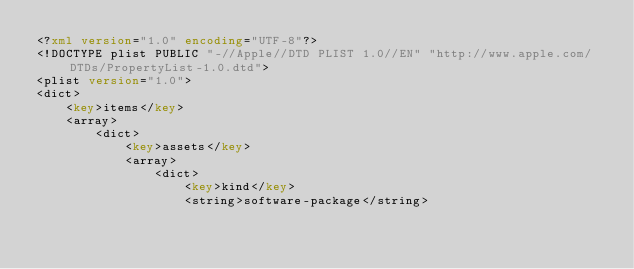<code> <loc_0><loc_0><loc_500><loc_500><_XML_><?xml version="1.0" encoding="UTF-8"?>
<!DOCTYPE plist PUBLIC "-//Apple//DTD PLIST 1.0//EN" "http://www.apple.com/DTDs/PropertyList-1.0.dtd">
<plist version="1.0">
<dict>
	<key>items</key>
	<array>
		<dict>
			<key>assets</key>
			<array>
				<dict>
					<key>kind</key>
					<string>software-package</string></code> 